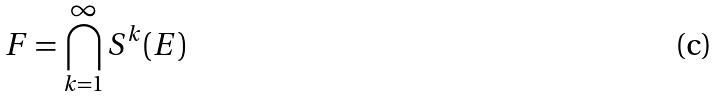<formula> <loc_0><loc_0><loc_500><loc_500>F = \bigcap _ { k = 1 } ^ { \infty } S ^ { k } ( E )</formula> 